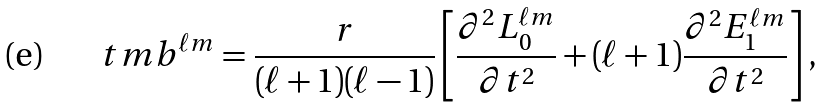<formula> <loc_0><loc_0><loc_500><loc_500>\ t m b ^ { \ell m } = \frac { r } { ( \ell + 1 ) ( \ell - 1 ) } \left [ \frac { \partial ^ { 2 } L _ { 0 } ^ { \ell m } } { \partial t ^ { 2 } } + ( \ell + 1 ) \frac { \partial ^ { 2 } E _ { 1 } ^ { \ell m } } { \partial t ^ { 2 } } \right ] ,</formula> 